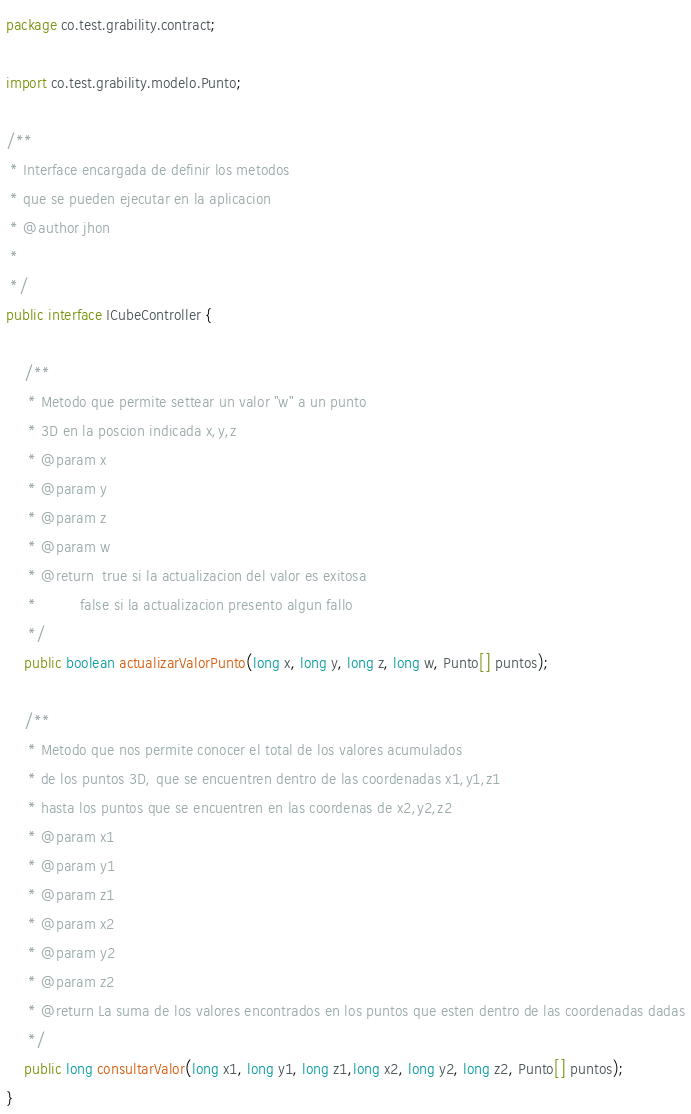<code> <loc_0><loc_0><loc_500><loc_500><_Java_>package co.test.grability.contract;

import co.test.grability.modelo.Punto;

/**
 * Interface encargada de definir los metodos 
 * que se pueden ejecutar en la aplicacion
 * @author jhon
 *
 */
public interface ICubeController {
	
	/**
	 * Metodo que permite settear un valor "w" a un punto 
	 * 3D en la poscion indicada x,y,z
	 * @param x
	 * @param y
	 * @param z
	 * @param w
	 * @return  true si la actualizacion del valor es exitosa
	 * 			false si la actualizacion presento algun fallo 
	 */
	public boolean actualizarValorPunto(long x, long y, long z, long w, Punto[] puntos);
	
	/**
	 * Metodo que nos permite conocer el total de los valores acumulados 
	 * de los puntos 3D, que se encuentren dentro de las coordenadas x1,y1,z1
	 * hasta los puntos que se encuentren en las coordenas de x2,y2,z2
	 * @param x1
	 * @param y1
	 * @param z1
	 * @param x2
	 * @param y2
	 * @param z2
	 * @return La suma de los valores encontrados en los puntos que esten dentro de las coordenadas dadas
	 */
	public long consultarValor(long x1, long y1, long z1,long x2, long y2, long z2, Punto[] puntos);
}
</code> 